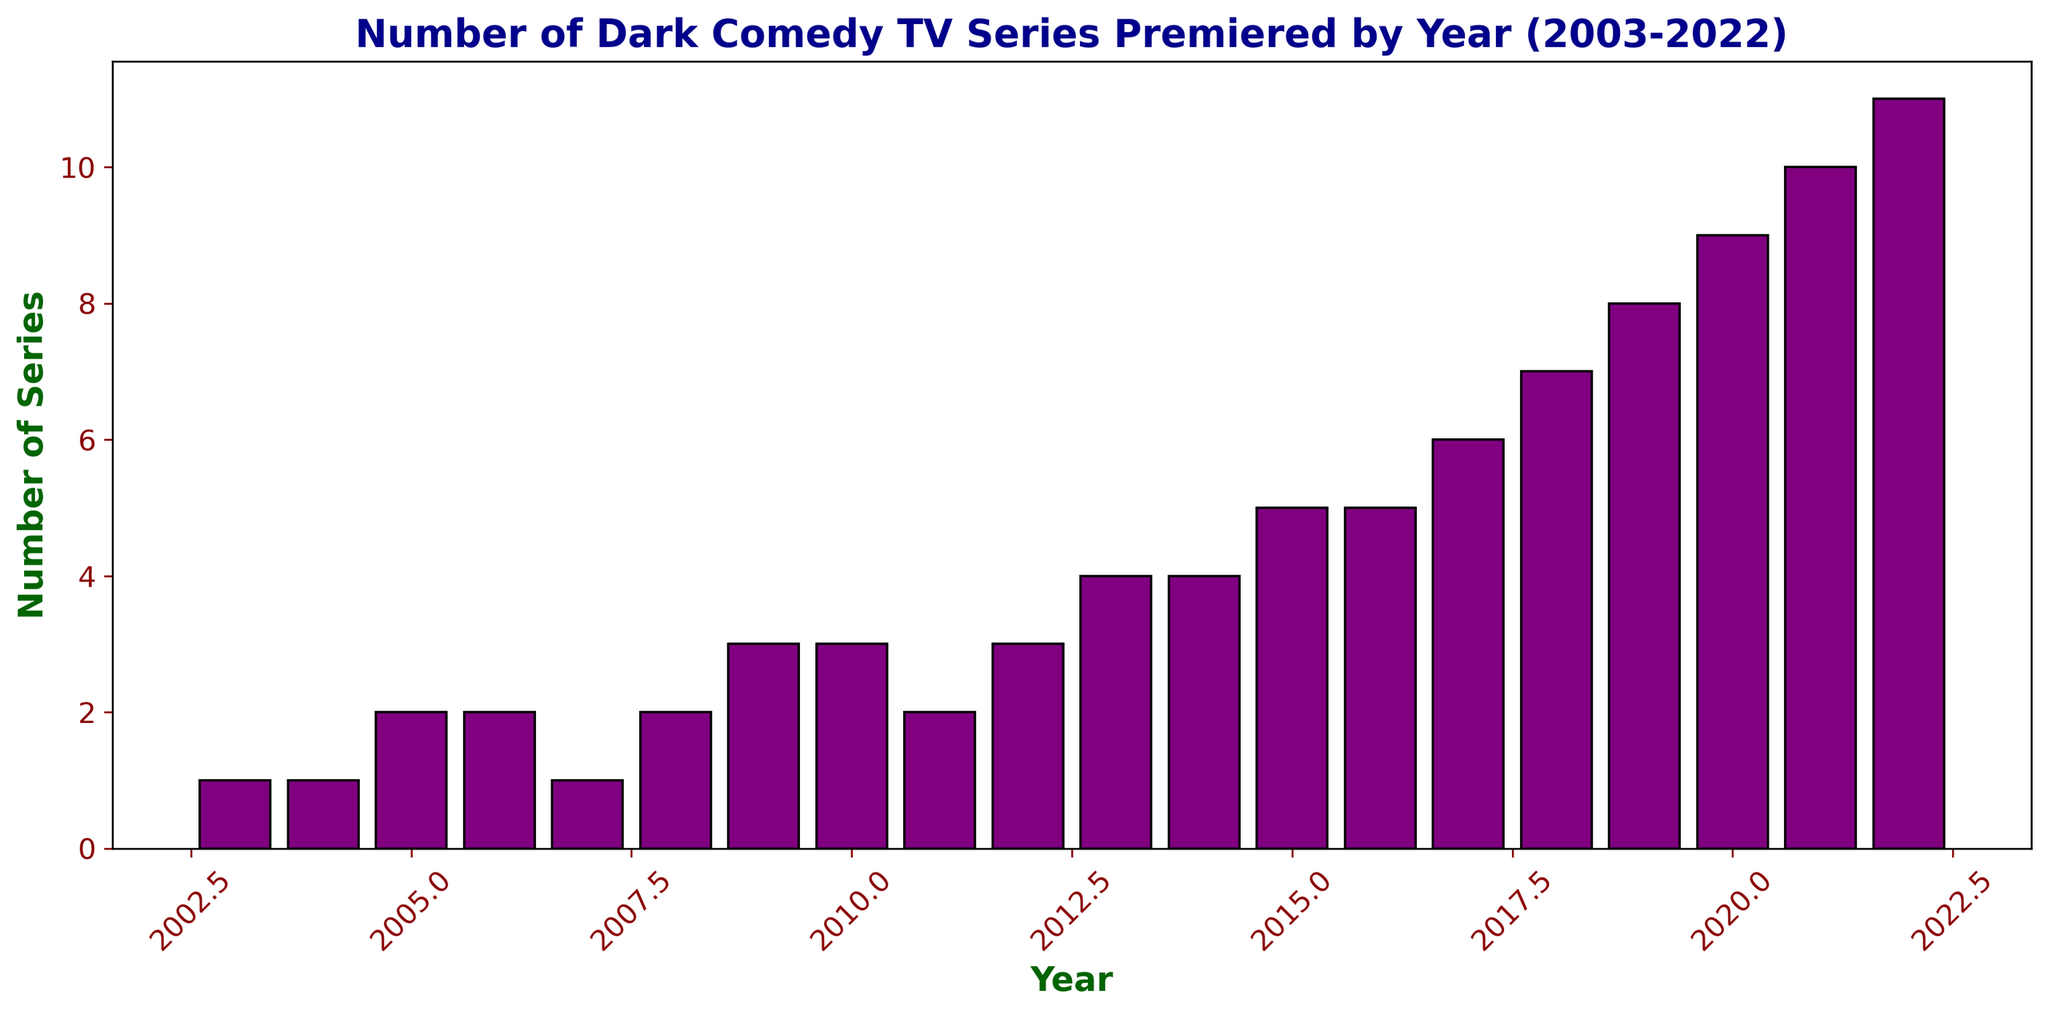What's the total number of dark comedy TV series that premiered from 2017 to 2022? Add the values for the years 2017, 2018, 2019, 2020, 2021, and 2022: 6 (2017) + 7 (2018) + 8 (2019) + 9 (2020) + 10 (2021) + 11 (2022) = 51
Answer: 51 Which year had the highest number of dark comedy TV series premieres? Look for the tallest bar in the histogram and read its corresponding year. The tallest bar is in the year 2022, with 11 series premiered.
Answer: 2022 How many more dark comedy TV series premiered in 2022 compared to 2003? Find the difference between the number of series in 2022 and 2003: 11 (2022) - 1 (2003) = 10
Answer: 10 Which year saw an increase of 2 series compared to the previous year? Identify the years where the difference in the number of series between consecutive years is 2. For example, 2004 to 2005 (1 to 2) and 2010 to 2011 (3 to 2).
Answer: 2005 and 2011 What's the average number of dark comedy TV series premiered per year from 2003 to 2022? Calculate the sum of all series premiered from 2003 to 2022 and divide by the number of years. Sum is 100 (sum of all years' series), and there are 20 years; so 100/20 = 5
Answer: 5 In which years was the number of dark comedy TV series premiered less than or equal to 3? Identify the years where the bar height is 3 or less: 2003, 2004, 2005, 2006, 2007, 2008, 2009, 2010, 2011, 2012.
Answer: 2003, 2004, 2005, 2006, 2007, 2008, 2009, 2010, 2011, 2012 In what year does the color of the bars change to purple? The color of all bars is purple, so there isn't a year where a change in color occurs. Hence, focus on recognizing the consistent visualization.
Answer: No change Which consecutive years had the same number of dark comedy TV series premiered? Find consecutive years with equal bar heights. The years 2005 and 2006 (2 series each), and 2013 and 2014 (4 series each) both have equal numbers.
Answer: 2005-2006 and 2013-2014 What is the total number of dark comedy TV series premiered in the first 10 years? Add the number of series from 2003 to 2012: 1 (2003) + 1 (2004) + 2 (2005) + 2 (2006) + 1 (2007) + 2 (2008) + 3 (2009) + 3 (2010) + 2 (2011) + 3 (2012) = 20
Answer: 20 What was the median number of dark comedy TV series premiered per year from 2003 to 2022? List out the series numbers: [1, 1, 2, 2, 1, 2, 3, 3, 2, 3, 4, 4, 5, 5, 6, 7, 8, 9, 10, 11]. The median, being the middle value, is between the 10th and 11th values (3 and 4), so the median is (3+4)/2 = 3.5
Answer: 3.5 